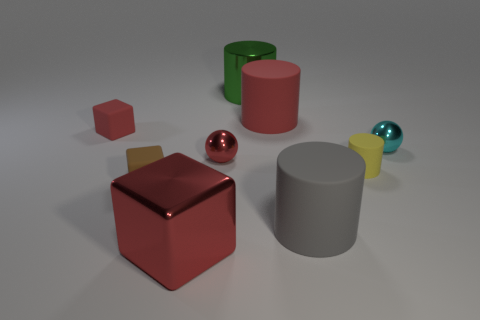The tiny red metallic object on the right side of the small rubber thing left of the small block that is in front of the tiny red matte block is what shape?
Provide a short and direct response. Sphere. There is a tiny red thing that is left of the large red cube; what is its shape?
Ensure brevity in your answer.  Cube. Is the material of the cyan ball the same as the tiny thing that is in front of the yellow cylinder?
Your answer should be compact. No. How many other things are there of the same shape as the tiny brown matte thing?
Your response must be concise. 2. There is a big block; is it the same color as the rubber cube that is behind the tiny red ball?
Make the answer very short. Yes. Is there anything else that has the same material as the green object?
Your response must be concise. Yes. What is the shape of the big matte object that is to the left of the big rubber object that is in front of the big red cylinder?
Give a very brief answer. Cylinder. What size is the cylinder that is the same color as the metallic block?
Give a very brief answer. Large. There is a small metal object that is left of the big red rubber object; does it have the same shape as the tiny cyan shiny thing?
Your answer should be very brief. Yes. Is the number of big matte cylinders to the right of the big gray cylinder greater than the number of matte cylinders to the left of the red metallic ball?
Keep it short and to the point. No. 